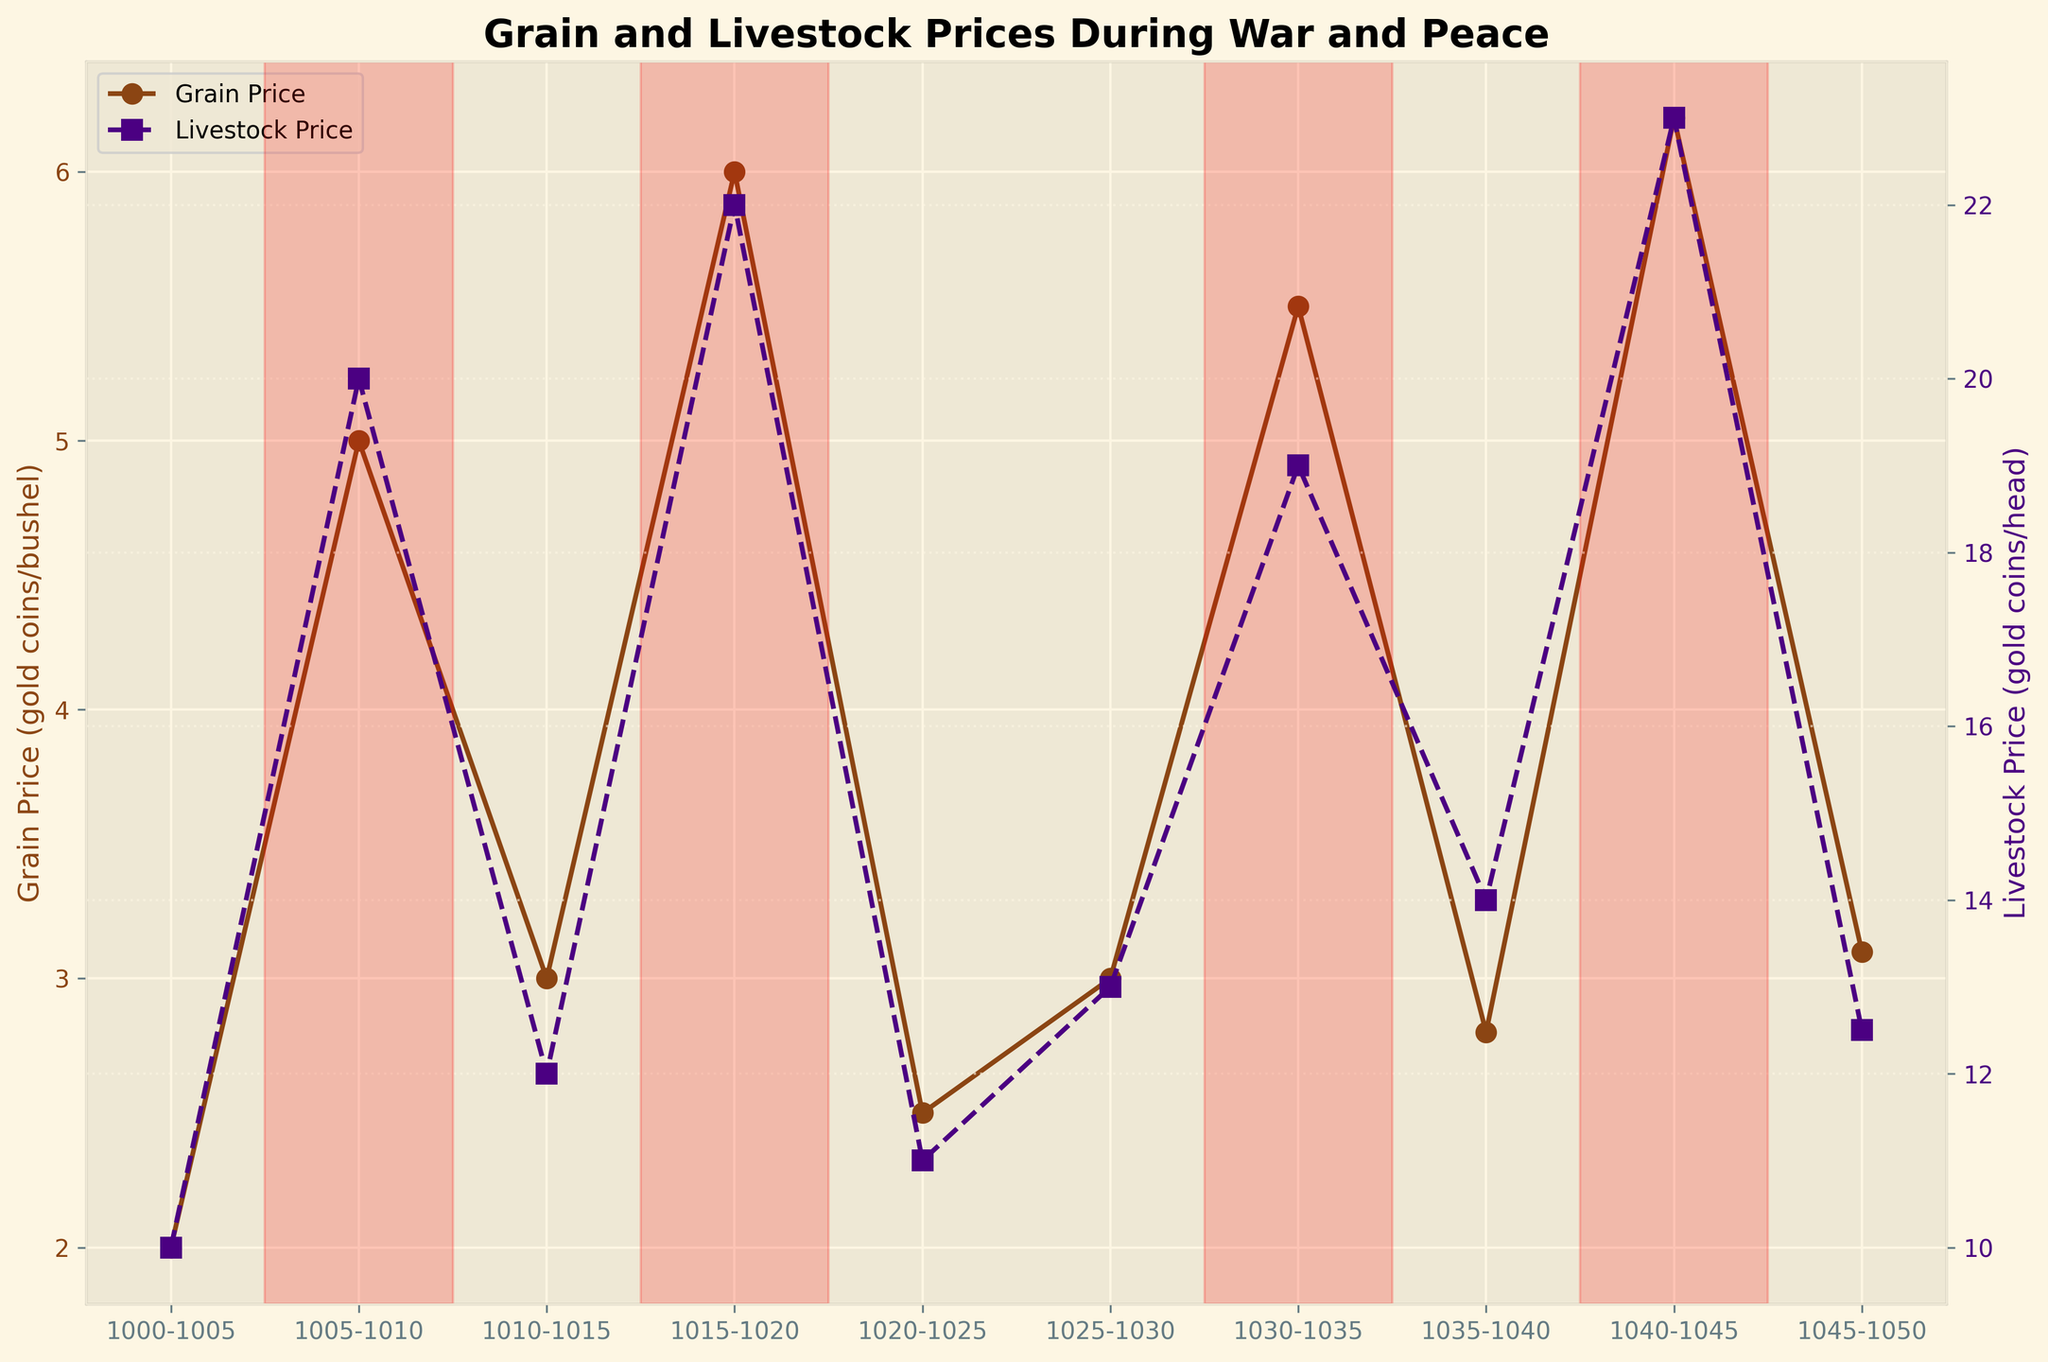What is the title of the figure? The title can be found at the top of the figure. Simply read it.
Answer: Grain and Livestock Prices During War and Peace What are the colors of the lines representing Grain and Livestock Prices? The colors of the lines can be identified by looking at the figure. The grain price line is brown, and the livestock price line is purple.
Answer: Brown and Purple How many periods indicate a state of war? The periods of war can be identified by the shaded red regions in the plot. Count these regions to find the number of periods.
Answer: Four periods During which periods were the prices of grain the highest? To find the highest prices, observe the peak points on the grain price line and identify the corresponding periods. The highest grain price peaks around 1040-1045.
Answer: 1040-1045 What is the average grain price during the times of war? Add the grain prices during war periods (5, 6, 5.5, and 6.2), then divide by the number of war periods to get the average. (5 + 6 + 5.5 + 6.2) / 4 = 22.7 / 4 = 5.675
Answer: 5.675 Compare the livestock prices during the first period of war and the last period of war. Which is higher? The livestock price in 1005-1010 (first war period) is 20, and in 1040-1045 (last war period) is 23. Compare these values.
Answer: 1040-1045 is higher Which period shows the largest difference between grain price and livestock price? For each period, subtract the grain price from the livestock price and find the period with the highest resulting value.
Answer: 1005-1010 How do the prices of grain compare during the periods 1030-1035 and 1035-1040? Compare the grain prices of these two periods by looking at the plot data points for both.
Answer: Grain prices were higher in 1030-1035 What are the average livestock prices during the periods of peace? Calculate the average of livestock prices during peace periods: (10 + 12 + 11 + 13 + 14 + 12.5) / 6 = 72.5 / 6 = 12.083
Answer: 12.083 During which period was the price of livestock the lowest? Look for the lowest point on the livestock price line and identify the corresponding period. The lowest price of livestock occurs in the first period, 1000-1005.
Answer: 1000-1005 